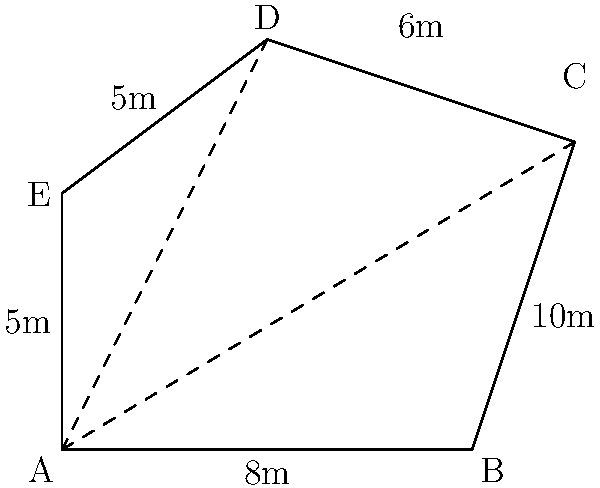As Gerontius, you're performing on an irregularly shaped stage for a special production of "The Dream of Gerontius." The stage is represented by the pentagon ABCDE in the diagram. Given the measurements shown, calculate the total area of the stage using triangulation. Let's approach this step-by-step:

1) We can divide the pentagon into three triangles: ABC, ACD, and ADE.

2) For triangle ABC:
   Base = 8m, Height = 6m
   Area of ABC = $\frac{1}{2} \times 8 \times 6 = 24$ m²

3) For triangle ACD:
   We need to find AC first using the Pythagorean theorem:
   $AC^2 = 8^2 + 6^2 = 100$
   $AC = 10$ m
   
   Now we can use Heron's formula. Let $s = (10 + 6 + 8) / 2 = 12$
   Area of ACD = $\sqrt{s(s-10)(s-6)(s-8)} = \sqrt{12(2)(6)(4)} = \sqrt{576} = 24$ m²

4) For triangle ADE:
   Base = 5m, Height = 4m (perpendicular distance from A to DE)
   Area of ADE = $\frac{1}{2} \times 5 \times 4 = 10$ m²

5) Total area = Area of ABC + Area of ACD + Area of ADE
               = $24 + 24 + 10 = 58$ m²
Answer: 58 m² 